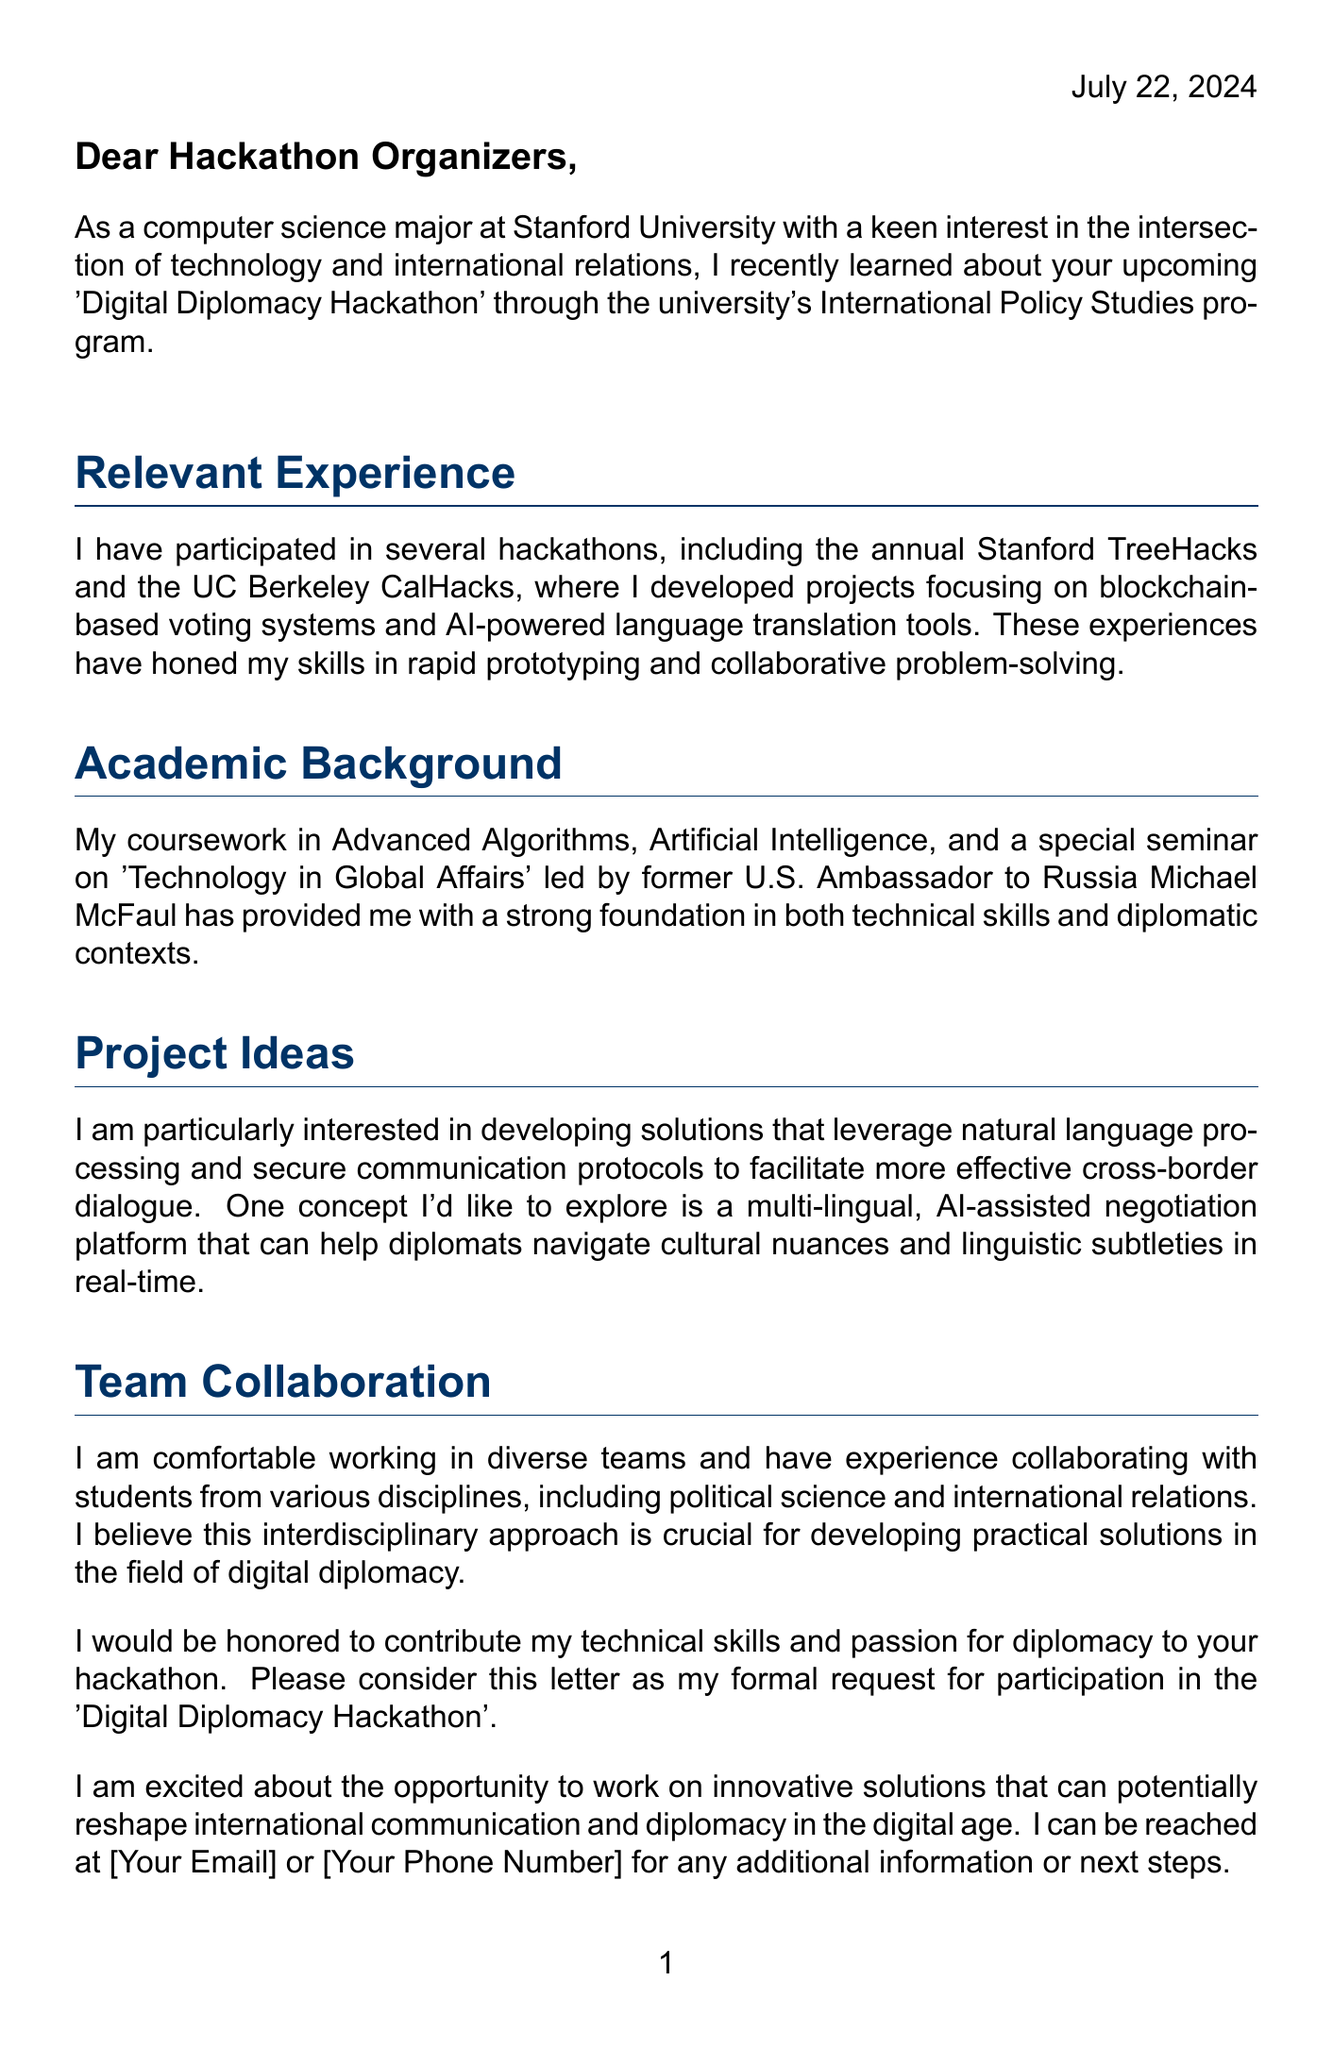What is the name of the hackathon? The hackathon is referred to as the 'Digital Diplomacy Hackathon' in the letter.
Answer: Digital Diplomacy Hackathon Who organized the hackathon? The organizers of the event are mentioned as the United Nations Office of Information and Communications Technology.
Answer: United Nations Office of Information and Communications Technology When is the hackathon scheduled? The date of the hackathon is specified in the document as October 15-17, 2023.
Answer: October 15-17, 2023 What university is the author attending? The document states that the author is a computer science major at Stanford University.
Answer: Stanford University What technologies are highlighted in the document? Several technologies are listed, including Artificial Intelligence, Natural Language Processing, and Blockchain among others.
Answer: Artificial Intelligence, Natural Language Processing, Blockchain What project idea is the author particularly interested in? The author expresses interest in a multi-lingual, AI-assisted negotiation platform that aids diplomats.
Answer: Multi-lingual, AI-assisted negotiation platform What level of collaboration does the author claim to be comfortable with? The author indicates comfort in working with diverse teams, showcasing their interdisciplinary collaborative experience.
Answer: Diverse teams What is the main theme of the hackathon? The main theme is stated as "Bridging Borders Through Technology."
Answer: Bridging Borders Through Technology 